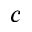<formula> <loc_0><loc_0><loc_500><loc_500>c</formula> 